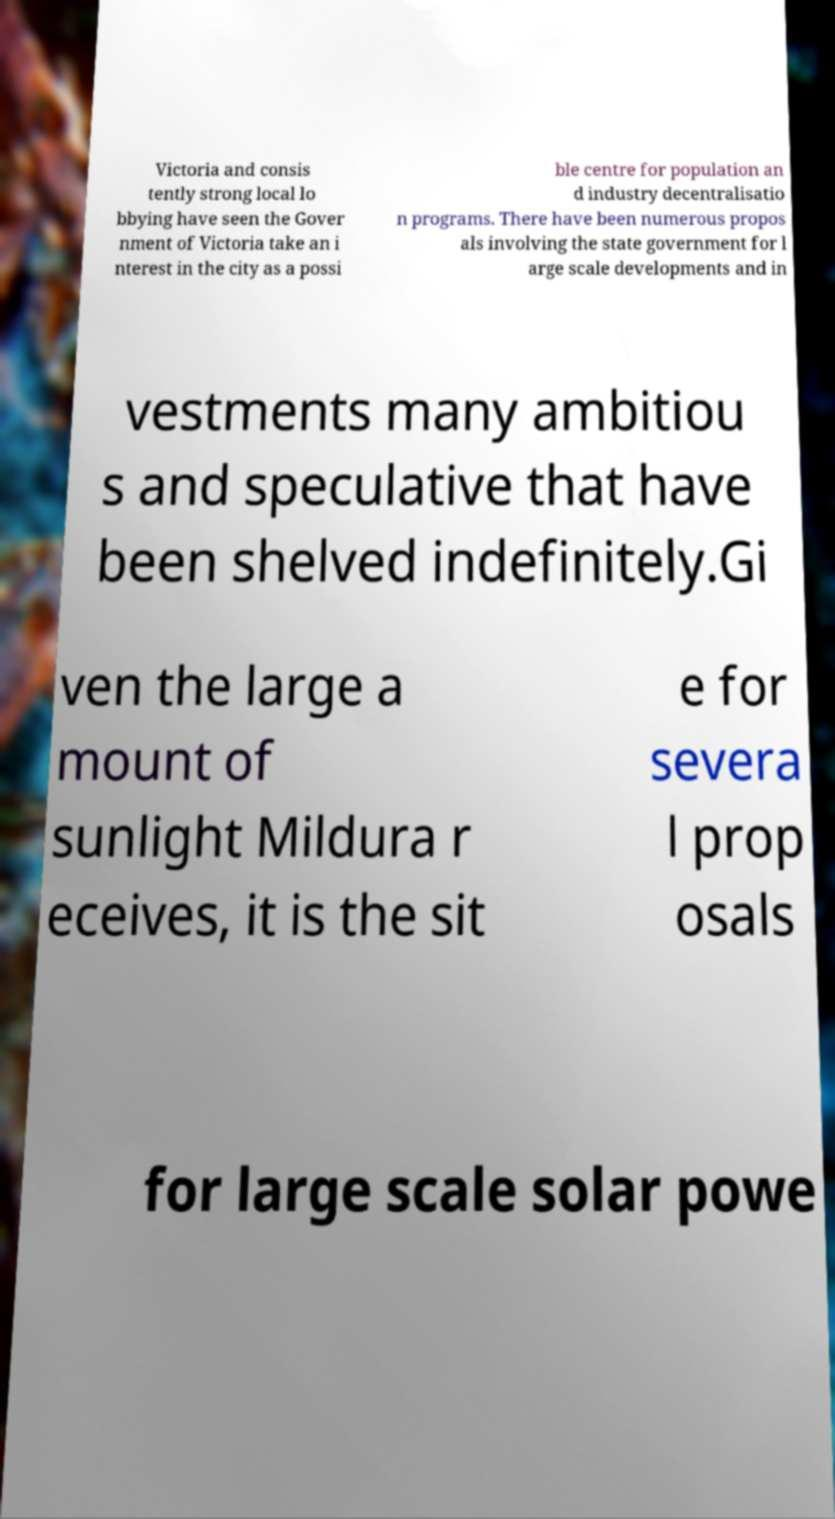Please read and relay the text visible in this image. What does it say? Victoria and consis tently strong local lo bbying have seen the Gover nment of Victoria take an i nterest in the city as a possi ble centre for population an d industry decentralisatio n programs. There have been numerous propos als involving the state government for l arge scale developments and in vestments many ambitiou s and speculative that have been shelved indefinitely.Gi ven the large a mount of sunlight Mildura r eceives, it is the sit e for severa l prop osals for large scale solar powe 